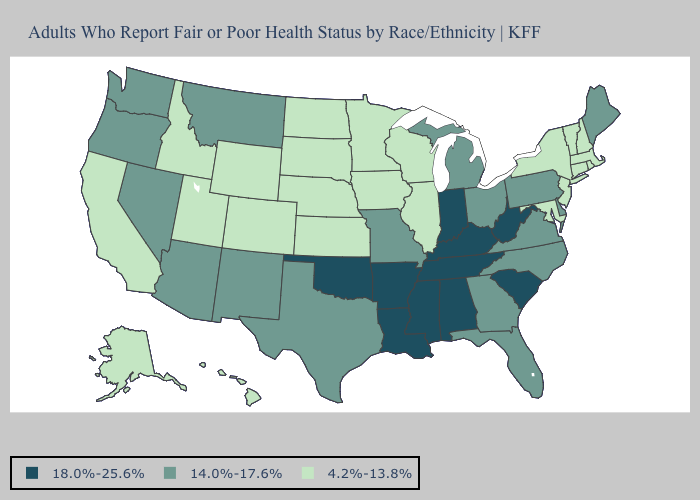Name the states that have a value in the range 18.0%-25.6%?
Concise answer only. Alabama, Arkansas, Indiana, Kentucky, Louisiana, Mississippi, Oklahoma, South Carolina, Tennessee, West Virginia. Among the states that border Utah , does Wyoming have the highest value?
Keep it brief. No. Which states have the lowest value in the USA?
Answer briefly. Alaska, California, Colorado, Connecticut, Hawaii, Idaho, Illinois, Iowa, Kansas, Maryland, Massachusetts, Minnesota, Nebraska, New Hampshire, New Jersey, New York, North Dakota, Rhode Island, South Dakota, Utah, Vermont, Wisconsin, Wyoming. Does the first symbol in the legend represent the smallest category?
Quick response, please. No. What is the value of Tennessee?
Answer briefly. 18.0%-25.6%. Which states hav the highest value in the South?
Keep it brief. Alabama, Arkansas, Kentucky, Louisiana, Mississippi, Oklahoma, South Carolina, Tennessee, West Virginia. What is the value of Arkansas?
Quick response, please. 18.0%-25.6%. What is the value of Utah?
Give a very brief answer. 4.2%-13.8%. Which states have the highest value in the USA?
Write a very short answer. Alabama, Arkansas, Indiana, Kentucky, Louisiana, Mississippi, Oklahoma, South Carolina, Tennessee, West Virginia. What is the lowest value in states that border Colorado?
Answer briefly. 4.2%-13.8%. Does the map have missing data?
Keep it brief. No. Does the first symbol in the legend represent the smallest category?
Keep it brief. No. What is the highest value in the USA?
Write a very short answer. 18.0%-25.6%. Name the states that have a value in the range 14.0%-17.6%?
Write a very short answer. Arizona, Delaware, Florida, Georgia, Maine, Michigan, Missouri, Montana, Nevada, New Mexico, North Carolina, Ohio, Oregon, Pennsylvania, Texas, Virginia, Washington. Among the states that border Connecticut , which have the highest value?
Quick response, please. Massachusetts, New York, Rhode Island. 